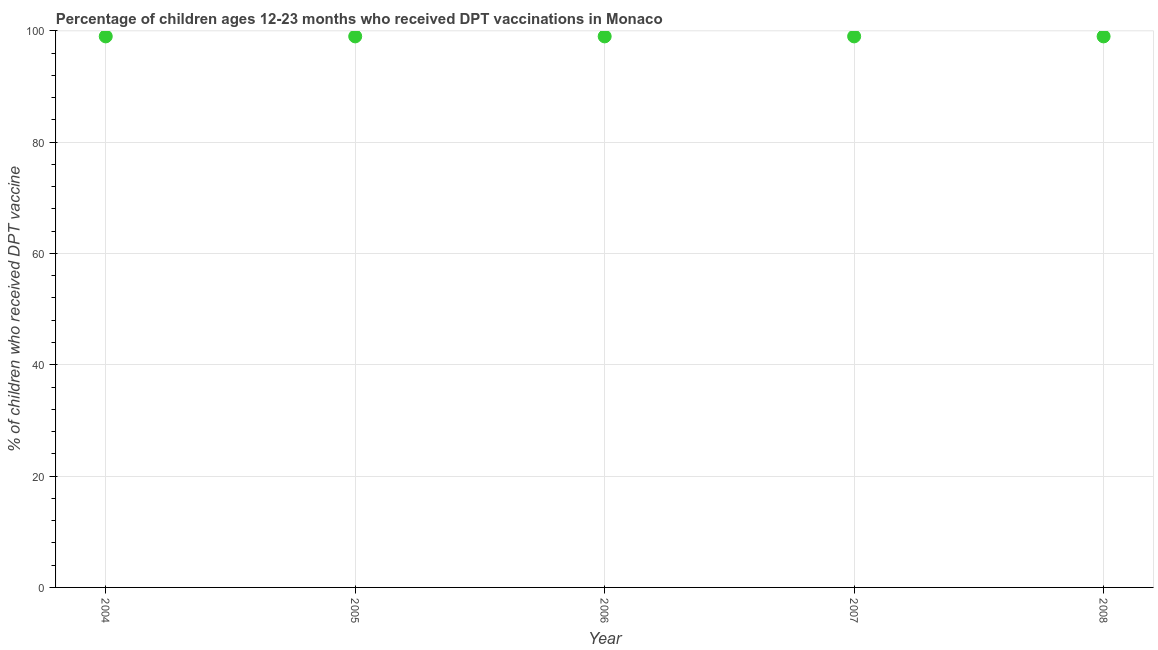What is the percentage of children who received dpt vaccine in 2008?
Ensure brevity in your answer.  99. Across all years, what is the maximum percentage of children who received dpt vaccine?
Keep it short and to the point. 99. Across all years, what is the minimum percentage of children who received dpt vaccine?
Your response must be concise. 99. What is the sum of the percentage of children who received dpt vaccine?
Make the answer very short. 495. What is the difference between the percentage of children who received dpt vaccine in 2005 and 2008?
Ensure brevity in your answer.  0. Is the percentage of children who received dpt vaccine in 2004 less than that in 2007?
Provide a succinct answer. No. Is the difference between the percentage of children who received dpt vaccine in 2007 and 2008 greater than the difference between any two years?
Your answer should be very brief. Yes. Is the sum of the percentage of children who received dpt vaccine in 2007 and 2008 greater than the maximum percentage of children who received dpt vaccine across all years?
Your answer should be very brief. Yes. What is the difference between the highest and the lowest percentage of children who received dpt vaccine?
Ensure brevity in your answer.  0. In how many years, is the percentage of children who received dpt vaccine greater than the average percentage of children who received dpt vaccine taken over all years?
Provide a short and direct response. 0. How many dotlines are there?
Your response must be concise. 1. How many years are there in the graph?
Your response must be concise. 5. What is the title of the graph?
Your answer should be compact. Percentage of children ages 12-23 months who received DPT vaccinations in Monaco. What is the label or title of the Y-axis?
Offer a very short reply. % of children who received DPT vaccine. What is the % of children who received DPT vaccine in 2007?
Offer a terse response. 99. What is the difference between the % of children who received DPT vaccine in 2004 and 2006?
Provide a short and direct response. 0. What is the difference between the % of children who received DPT vaccine in 2004 and 2008?
Your response must be concise. 0. What is the difference between the % of children who received DPT vaccine in 2005 and 2006?
Provide a short and direct response. 0. What is the difference between the % of children who received DPT vaccine in 2005 and 2008?
Provide a short and direct response. 0. What is the difference between the % of children who received DPT vaccine in 2007 and 2008?
Your answer should be very brief. 0. What is the ratio of the % of children who received DPT vaccine in 2004 to that in 2005?
Your response must be concise. 1. What is the ratio of the % of children who received DPT vaccine in 2005 to that in 2007?
Provide a succinct answer. 1. What is the ratio of the % of children who received DPT vaccine in 2006 to that in 2008?
Your answer should be compact. 1. 